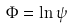<formula> <loc_0><loc_0><loc_500><loc_500>\Phi = \ln \psi</formula> 